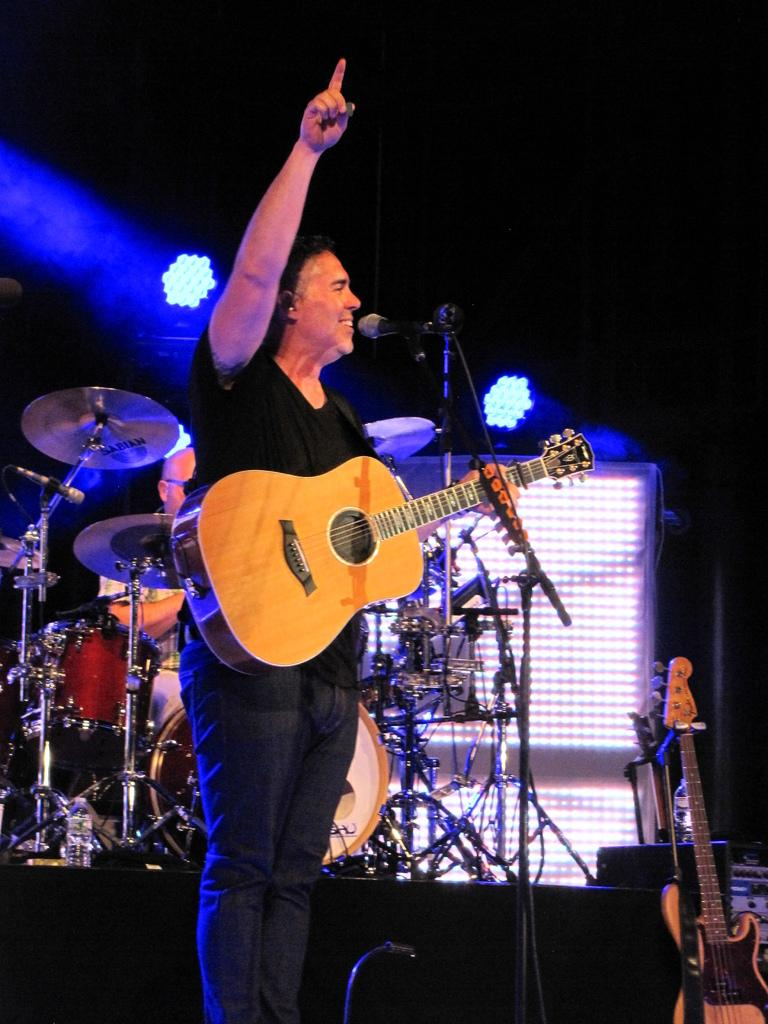Who is the main subject in the image? There is a man in the image. What is the man holding in the image? The man is holding a guitar. What expression does the man have in the image? The man is smiling. What other objects can be seen in the image? There is a microphone and a stand in the image. What type of coal is being used to fuel the man's performance in the image? There is no coal present in the image, and it does not depict a performance being fueled by coal. 